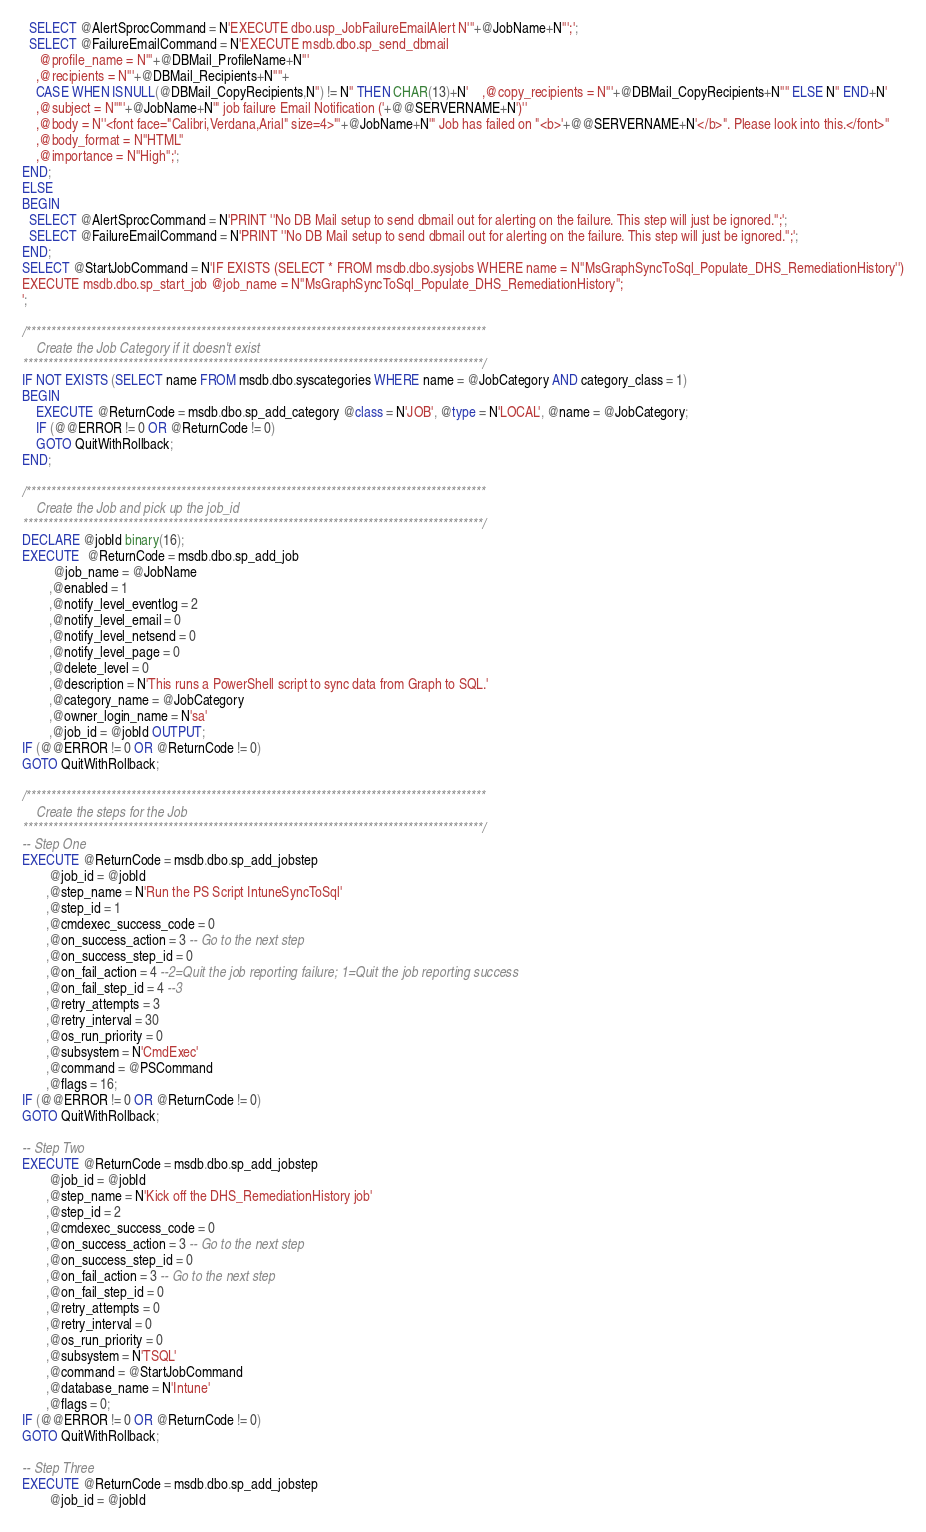<code> <loc_0><loc_0><loc_500><loc_500><_SQL_>  SELECT @AlertSprocCommand = N'EXECUTE dbo.usp_JobFailureEmailAlert N'''+@JobName+N''';';
  SELECT @FailureEmailCommand = N'EXECUTE msdb.dbo.sp_send_dbmail
     @profile_name = N'''+@DBMail_ProfileName+N'''
	,@recipients = N'''+@DBMail_Recipients+N''''+
	CASE WHEN ISNULL(@DBMail_CopyRecipients,N'') != N'' THEN CHAR(13)+N'    ,@copy_recipients = N'''+@DBMail_CopyRecipients+N'''' ELSE N'' END+N'
	,@subject = N''"'+@JobName+N'" job failure Email Notification ('+@@SERVERNAME+N')''
	,@body = N''<font face="Calibri,Verdana,Arial" size=4>"'+@JobName+N'" Job has failed on "<b>'+@@SERVERNAME+N'</b>". Please look into this.</font>''
	,@body_format = N''HTML''
	,@importance = N''High'';';
END;
ELSE
BEGIN
  SELECT @AlertSprocCommand = N'PRINT ''No DB Mail setup to send dbmail out for alerting on the failure. This step will just be ignored.'';';
  SELECT @FailureEmailCommand = N'PRINT ''No DB Mail setup to send dbmail out for alerting on the failure. This step will just be ignored.'';';
END;
SELECT @StartJobCommand = N'IF EXISTS (SELECT * FROM msdb.dbo.sysjobs WHERE name = N''MsGraphSyncToSql_Populate_DHS_RemediationHistory'')
EXECUTE msdb.dbo.sp_start_job @job_name = N''MsGraphSyncToSql_Populate_DHS_RemediationHistory'';
';

/********************************************************************************************
    Create the Job Category if it doesn't exist
********************************************************************************************/
IF NOT EXISTS (SELECT name FROM msdb.dbo.syscategories WHERE name = @JobCategory AND category_class = 1)
BEGIN
    EXECUTE @ReturnCode = msdb.dbo.sp_add_category @class = N'JOB', @type = N'LOCAL', @name = @JobCategory;
    IF (@@ERROR != 0 OR @ReturnCode != 0)
    GOTO QuitWithRollback;
END;

/********************************************************************************************
    Create the Job and pick up the job_id
********************************************************************************************/
DECLARE @jobId binary(16);
EXECUTE  @ReturnCode = msdb.dbo.sp_add_job 
         @job_name = @JobName
        ,@enabled = 1
        ,@notify_level_eventlog = 2
        ,@notify_level_email = 0
        ,@notify_level_netsend = 0
        ,@notify_level_page = 0
        ,@delete_level = 0
        ,@description = N'This runs a PowerShell script to sync data from Graph to SQL.'
        ,@category_name = @JobCategory
        ,@owner_login_name = N'sa'
        ,@job_id = @jobId OUTPUT;
IF (@@ERROR != 0 OR @ReturnCode != 0)
GOTO QuitWithRollback;

/********************************************************************************************
    Create the steps for the Job
********************************************************************************************/
-- Step One
EXECUTE @ReturnCode = msdb.dbo.sp_add_jobstep
        @job_id = @jobId
       ,@step_name = N'Run the PS Script IntuneSyncToSql'
       ,@step_id = 1
       ,@cmdexec_success_code = 0
       ,@on_success_action = 3 -- Go to the next step
       ,@on_success_step_id = 0
       ,@on_fail_action = 4 --2=Quit the job reporting failure; 1=Quit the job reporting success
       ,@on_fail_step_id = 4 --3
       ,@retry_attempts = 3
       ,@retry_interval = 30
       ,@os_run_priority = 0
       ,@subsystem = N'CmdExec'
       ,@command = @PSCommand
       ,@flags = 16;
IF (@@ERROR != 0 OR @ReturnCode != 0)
GOTO QuitWithRollback;

-- Step Two
EXECUTE @ReturnCode = msdb.dbo.sp_add_jobstep
        @job_id = @jobId
       ,@step_name = N'Kick off the DHS_RemediationHistory job'
       ,@step_id = 2
       ,@cmdexec_success_code = 0
       ,@on_success_action = 3 -- Go to the next step
       ,@on_success_step_id = 0
       ,@on_fail_action = 3 -- Go to the next step
       ,@on_fail_step_id = 0
       ,@retry_attempts = 0
       ,@retry_interval = 0
       ,@os_run_priority = 0
       ,@subsystem = N'TSQL'
       ,@command = @StartJobCommand
       ,@database_name = N'Intune'
       ,@flags = 0;
IF (@@ERROR != 0 OR @ReturnCode != 0)
GOTO QuitWithRollback;

-- Step Three
EXECUTE @ReturnCode = msdb.dbo.sp_add_jobstep
        @job_id = @jobId</code> 